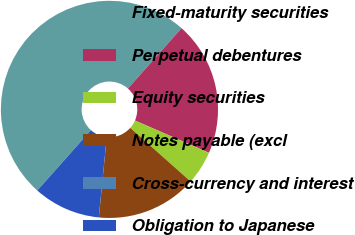<chart> <loc_0><loc_0><loc_500><loc_500><pie_chart><fcel>Fixed-maturity securities<fcel>Perpetual debentures<fcel>Equity securities<fcel>Notes payable (excl<fcel>Cross-currency and interest<fcel>Obligation to Japanese<nl><fcel>49.98%<fcel>20.0%<fcel>5.01%<fcel>15.0%<fcel>0.01%<fcel>10.0%<nl></chart> 